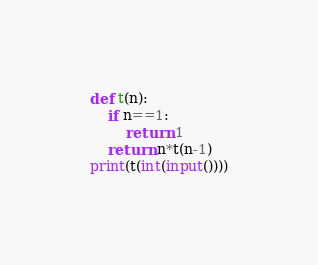<code> <loc_0><loc_0><loc_500><loc_500><_Python_>def t(n):
    if n==1:
        return 1
    return n*t(n-1)
print(t(int(input())))</code> 